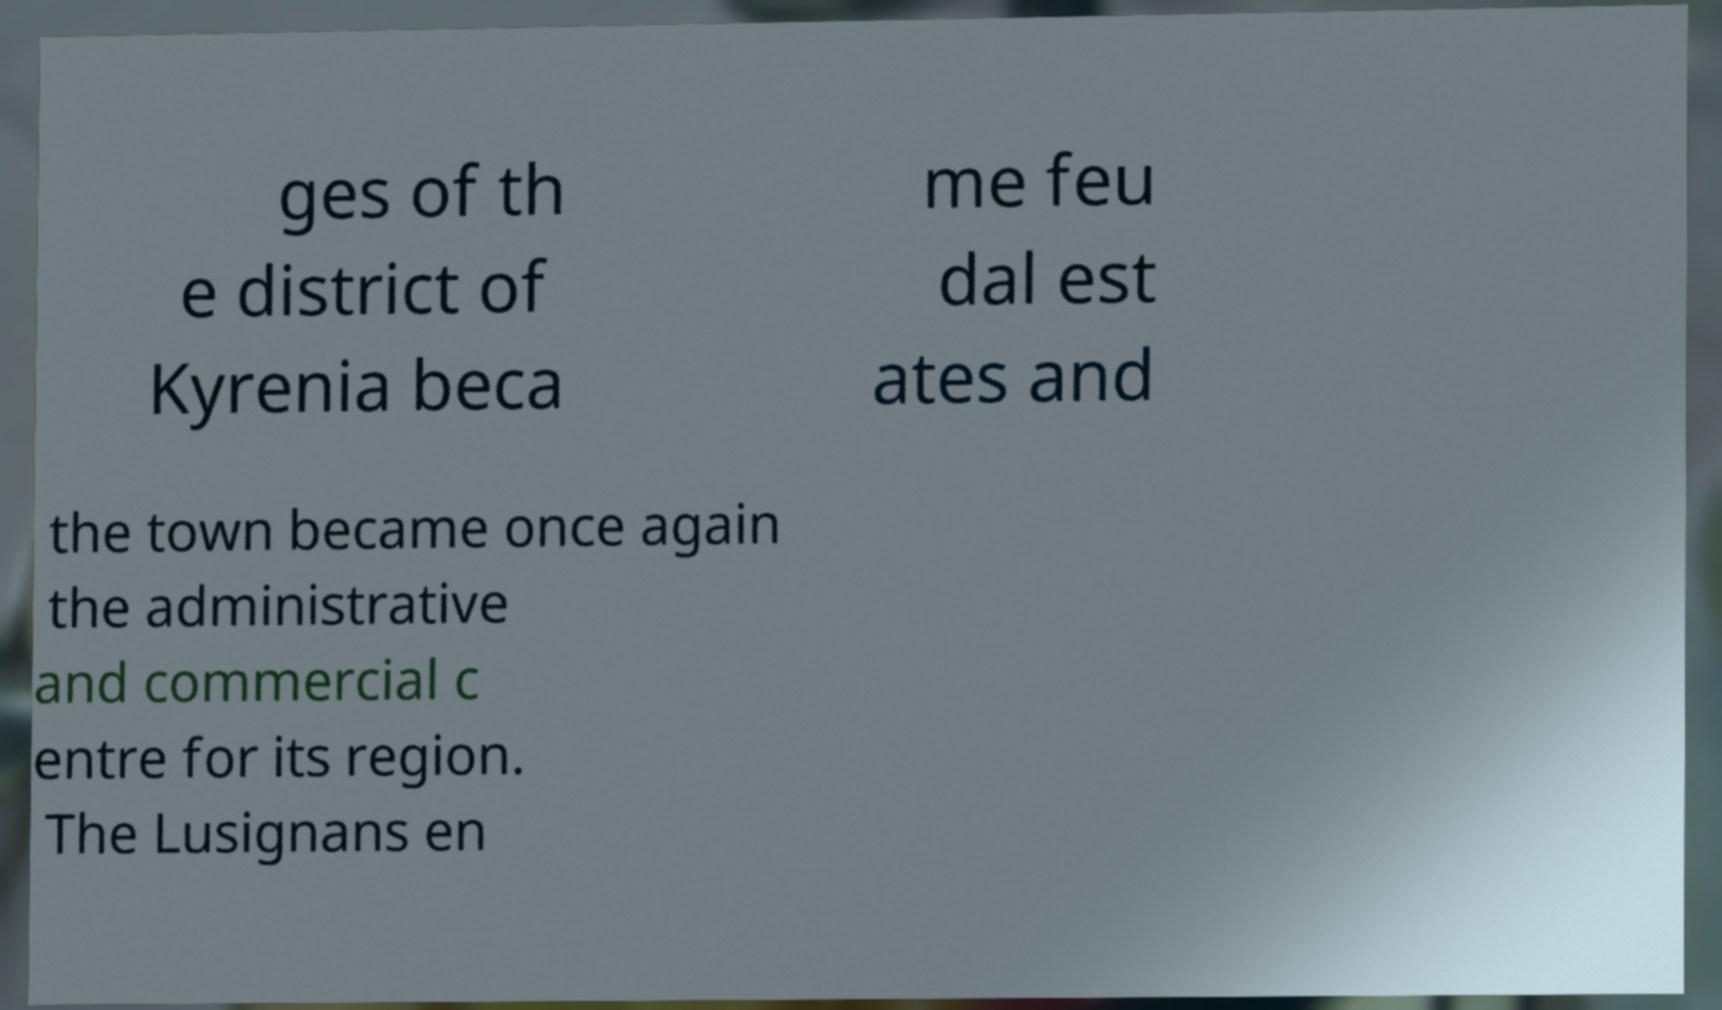Can you read and provide the text displayed in the image?This photo seems to have some interesting text. Can you extract and type it out for me? ges of th e district of Kyrenia beca me feu dal est ates and the town became once again the administrative and commercial c entre for its region. The Lusignans en 